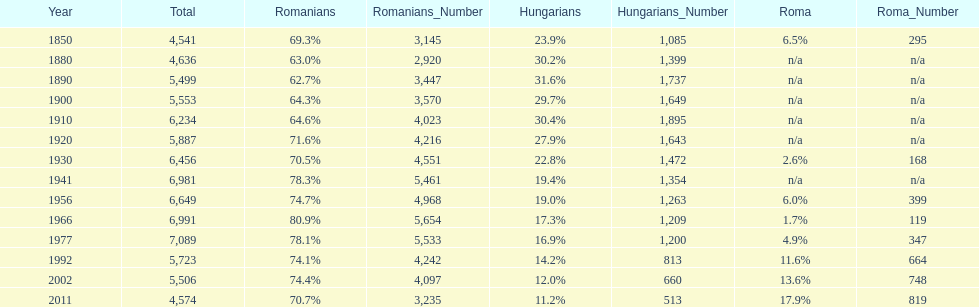Which year is previous to the year that had 74.1% in romanian population? 1977. 